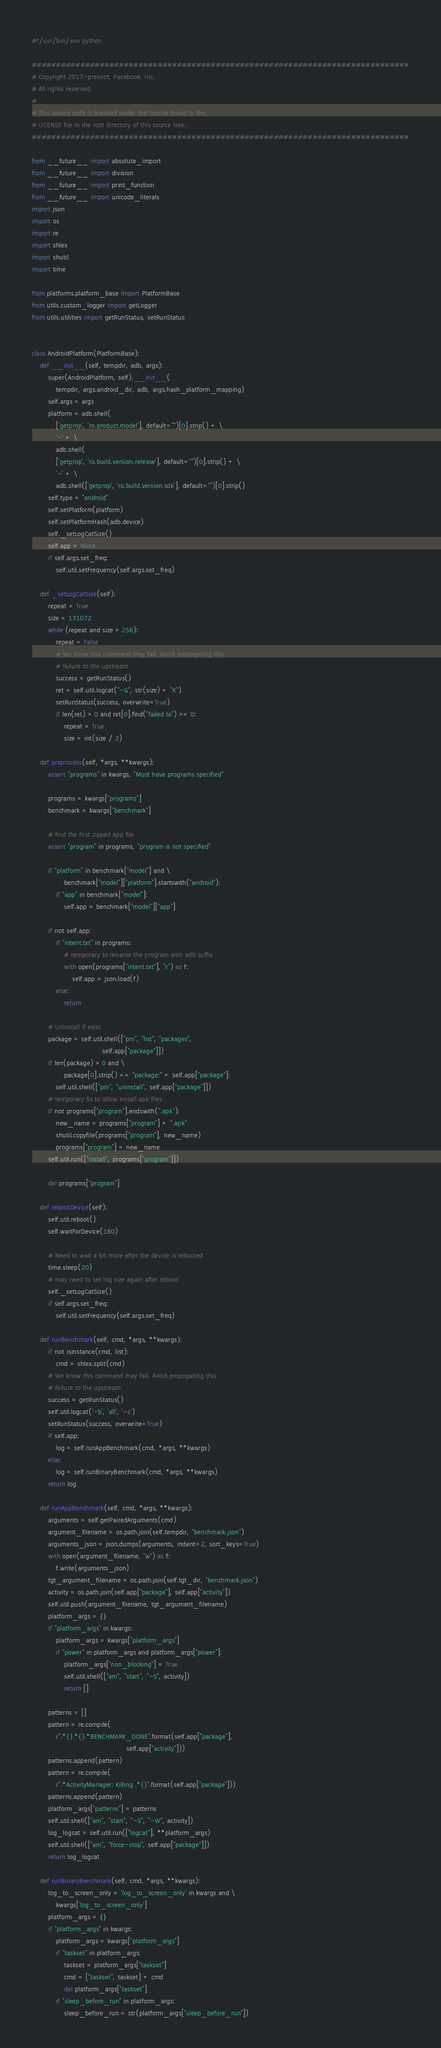<code> <loc_0><loc_0><loc_500><loc_500><_Python_>#!/usr/bin/env python

##############################################################################
# Copyright 2017-present, Facebook, Inc.
# All rights reserved.
#
# This source code is licensed under the license found in the
# LICENSE file in the root directory of this source tree.
##############################################################################

from __future__ import absolute_import
from __future__ import division
from __future__ import print_function
from __future__ import unicode_literals
import json
import os
import re
import shlex
import shutil
import time

from platforms.platform_base import PlatformBase
from utils.custom_logger import getLogger
from utils.utilities import getRunStatus, setRunStatus


class AndroidPlatform(PlatformBase):
    def __init__(self, tempdir, adb, args):
        super(AndroidPlatform, self).__init__(
            tempdir, args.android_dir, adb, args.hash_platform_mapping)
        self.args = args
        platform = adb.shell(
            ['getprop', 'ro.product.model'], default="")[0].strip() + \
            '-' + \
            adb.shell(
            ['getprop', 'ro.build.version.release'], default="")[0].strip() + \
            '-' + \
            adb.shell(['getprop', 'ro.build.version.sdk'], default="")[0].strip()
        self.type = "android"
        self.setPlatform(platform)
        self.setPlatformHash(adb.device)
        self._setLogCatSize()
        self.app = None
        if self.args.set_freq:
            self.util.setFrequency(self.args.set_freq)

    def _setLogCatSize(self):
        repeat = True
        size = 131072
        while (repeat and size > 256):
            repeat = False
            # We know this command may fail. Avoid propogating this
            # failure to the upstream
            success = getRunStatus()
            ret = self.util.logcat("-G", str(size) + "K")
            setRunStatus(success, overwrite=True)
            if len(ret) > 0 and ret[0].find("failed to") >= 0:
                repeat = True
                size = int(size / 2)

    def preprocess(self, *args, **kwargs):
        assert "programs" in kwargs, "Must have programs specified"

        programs = kwargs["programs"]
        benchmark = kwargs["benchmark"]

        # find the first zipped app file
        assert "program" in programs, "program is not specified"

        if "platform" in benchmark["model"] and \
                benchmark["model"]["platform"].startswith("android"):
            if "app" in benchmark["model"]:
                self.app = benchmark["model"]["app"]

        if not self.app:
            if "intent.txt" in programs:
                # temporary to rename the program with adb suffix
                with open(programs["intent.txt"], "r") as f:
                    self.app = json.load(f)
            else:
                return

        # Uninstall if exist
        package = self.util.shell(["pm", "list", "packages",
                                   self.app["package"]])
        if len(package) > 0 and \
                package[0].strip() == "package:" + self.app["package"]:
            self.util.shell(["pm", "uninstall", self.app["package"]])
        # temporary fix to allow install apk files
        if not programs["program"].endswith(".apk"):
            new_name = programs["program"] + ".apk"
            shutil.copyfile(programs["program"], new_name)
            programs["program"] = new_name
        self.util.run(["install", programs["program"]])

        del programs["program"]

    def rebootDevice(self):
        self.util.reboot()
        self.waitForDevice(180)

        # Need to wait a bit more after the device is rebooted
        time.sleep(20)
        # may need to set log size again after reboot
        self._setLogCatSize()
        if self.args.set_freq:
            self.util.setFrequency(self.args.set_freq)

    def runBenchmark(self, cmd, *args, **kwargs):
        if not isinstance(cmd, list):
            cmd = shlex.split(cmd)
        # We know this command may fail. Avoid propogating this
        # failure to the upstream
        success = getRunStatus()
        self.util.logcat('-b', 'all', '-c')
        setRunStatus(success, overwrite=True)
        if self.app:
            log = self.runAppBenchmark(cmd, *args, **kwargs)
        else:
            log = self.runBinaryBenchmark(cmd, *args, **kwargs)
        return log

    def runAppBenchmark(self, cmd, *args, **kwargs):
        arguments = self.getPairedArguments(cmd)
        argument_filename = os.path.join(self.tempdir, "benchmark.json")
        arguments_json = json.dumps(arguments, indent=2, sort_keys=True)
        with open(argument_filename, "w") as f:
            f.write(arguments_json)
        tgt_argument_filename = os.path.join(self.tgt_dir, "benchmark.json")
        activity = os.path.join(self.app["package"], self.app["activity"])
        self.util.push(argument_filename, tgt_argument_filename)
        platform_args = {}
        if "platform_args" in kwargs:
            platform_args = kwargs["platform_args"]
            if "power" in platform_args and platform_args["power"]:
                platform_args["non_blocking"] = True
                self.util.shell(["am", "start", "-S", activity])
                return []

        patterns = []
        pattern = re.compile(
            r".*{}.*{}.*BENCHMARK_DONE".format(self.app["package"],
                                               self.app["activity"]))
        patterns.append(pattern)
        pattern = re.compile(
            r".*ActivityManager: Killing .*{}".format(self.app["package"]))
        patterns.append(pattern)
        platform_args["patterns"] = patterns
        self.util.shell(["am", "start", "-S", "-W", activity])
        log_logcat = self.util.run(["logcat"], **platform_args)
        self.util.shell(["am", "force-stop", self.app["package"]])
        return log_logcat

    def runBinaryBenchmark(self, cmd, *args, **kwargs):
        log_to_screen_only = 'log_to_screen_only' in kwargs and \
            kwargs['log_to_screen_only']
        platform_args = {}
        if "platform_args" in kwargs:
            platform_args = kwargs["platform_args"]
            if "taskset" in platform_args:
                taskset = platform_args["taskset"]
                cmd = ["taskset", taskset] + cmd
                del platform_args["taskset"]
            if "sleep_before_run" in platform_args:
                sleep_before_run = str(platform_args["sleep_before_run"])</code> 